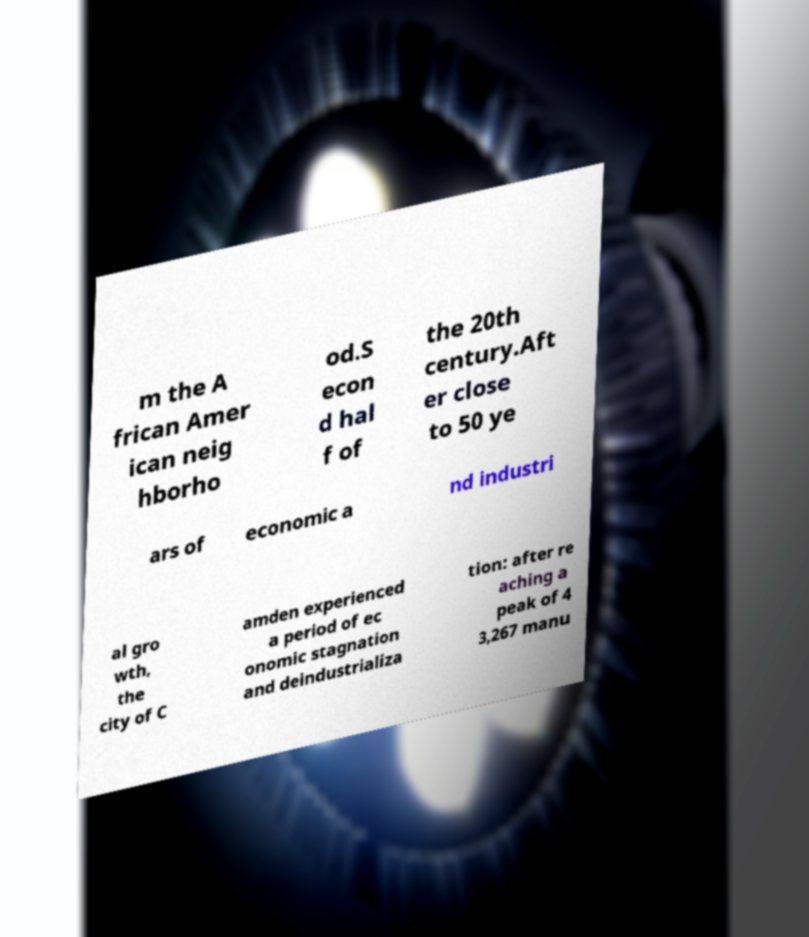I need the written content from this picture converted into text. Can you do that? m the A frican Amer ican neig hborho od.S econ d hal f of the 20th century.Aft er close to 50 ye ars of economic a nd industri al gro wth, the city of C amden experienced a period of ec onomic stagnation and deindustrializa tion: after re aching a peak of 4 3,267 manu 